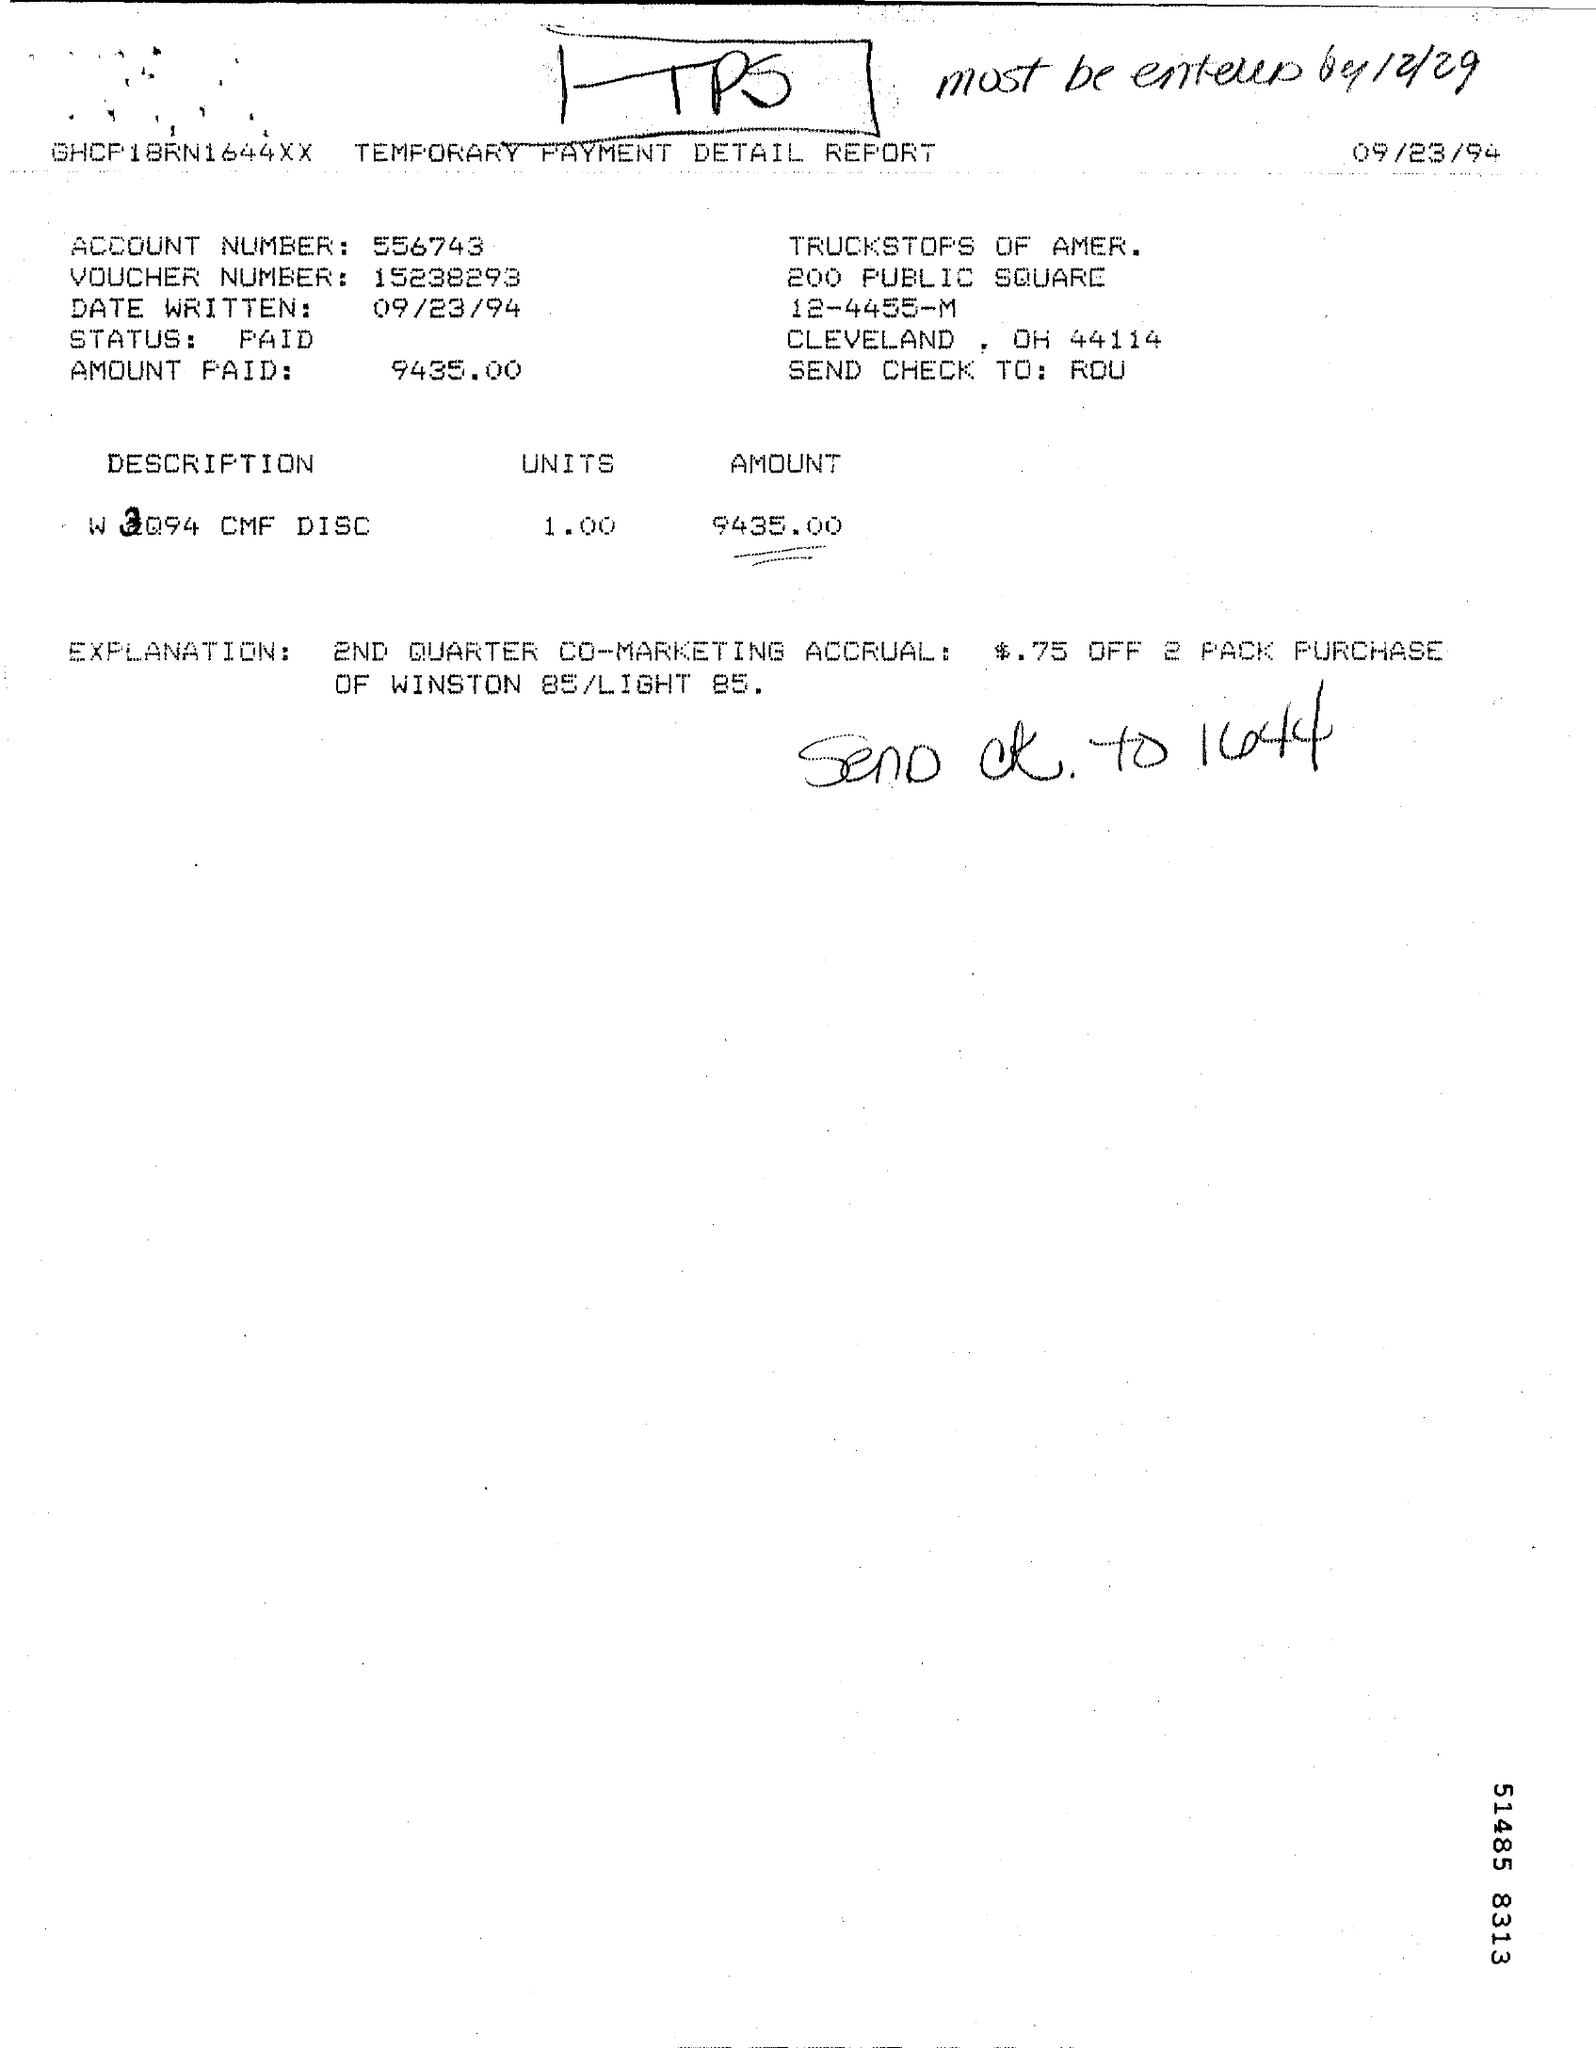Indicate a few pertinent items in this graphic. The account number mentioned in the given page is 556743... The status shown on the given page is "PAID.." which conveys that the item has been paid. Can you please provide me with the voucher number mentioned on the given page, which is 15238293... The report shows that $9,435 was paid. The date written in the given page is September 23, 1994. 